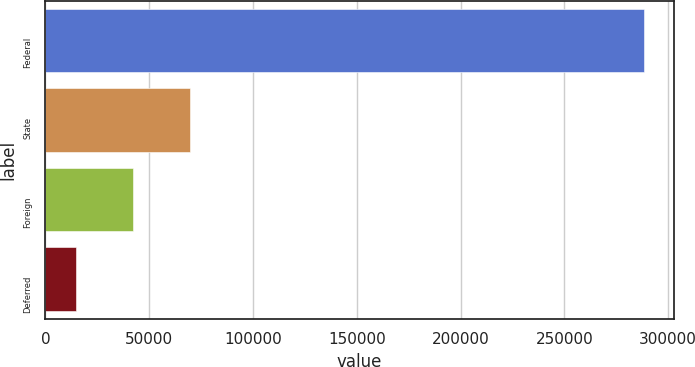Convert chart to OTSL. <chart><loc_0><loc_0><loc_500><loc_500><bar_chart><fcel>Federal<fcel>State<fcel>Foreign<fcel>Deferred<nl><fcel>288135<fcel>69427.8<fcel>42089.4<fcel>14751<nl></chart> 